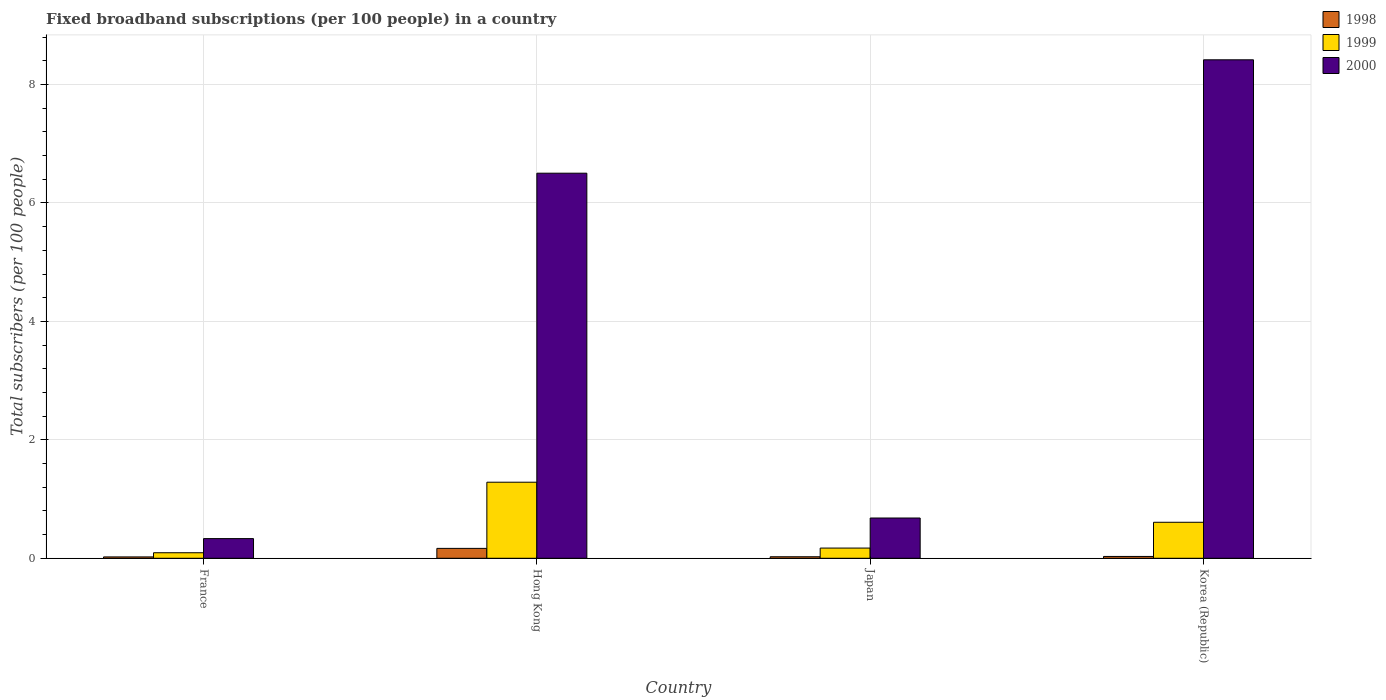How many different coloured bars are there?
Provide a succinct answer. 3. How many groups of bars are there?
Make the answer very short. 4. How many bars are there on the 3rd tick from the left?
Ensure brevity in your answer.  3. What is the label of the 4th group of bars from the left?
Provide a succinct answer. Korea (Republic). What is the number of broadband subscriptions in 2000 in Hong Kong?
Your answer should be very brief. 6.5. Across all countries, what is the maximum number of broadband subscriptions in 1998?
Ensure brevity in your answer.  0.17. Across all countries, what is the minimum number of broadband subscriptions in 2000?
Your response must be concise. 0.33. In which country was the number of broadband subscriptions in 1998 maximum?
Provide a short and direct response. Hong Kong. In which country was the number of broadband subscriptions in 2000 minimum?
Offer a very short reply. France. What is the total number of broadband subscriptions in 1998 in the graph?
Provide a succinct answer. 0.25. What is the difference between the number of broadband subscriptions in 2000 in Japan and that in Korea (Republic)?
Provide a succinct answer. -7.74. What is the difference between the number of broadband subscriptions in 2000 in France and the number of broadband subscriptions in 1998 in Japan?
Offer a very short reply. 0.31. What is the average number of broadband subscriptions in 2000 per country?
Make the answer very short. 3.98. What is the difference between the number of broadband subscriptions of/in 2000 and number of broadband subscriptions of/in 1998 in Korea (Republic)?
Make the answer very short. 8.39. In how many countries, is the number of broadband subscriptions in 1998 greater than 4.8?
Make the answer very short. 0. What is the ratio of the number of broadband subscriptions in 1999 in France to that in Korea (Republic)?
Provide a succinct answer. 0.15. What is the difference between the highest and the second highest number of broadband subscriptions in 1998?
Make the answer very short. 0.14. What is the difference between the highest and the lowest number of broadband subscriptions in 2000?
Ensure brevity in your answer.  8.09. In how many countries, is the number of broadband subscriptions in 1998 greater than the average number of broadband subscriptions in 1998 taken over all countries?
Your response must be concise. 1. What does the 3rd bar from the left in France represents?
Give a very brief answer. 2000. What does the 1st bar from the right in Japan represents?
Provide a succinct answer. 2000. How many bars are there?
Your answer should be compact. 12. Are all the bars in the graph horizontal?
Give a very brief answer. No. What is the difference between two consecutive major ticks on the Y-axis?
Ensure brevity in your answer.  2. Where does the legend appear in the graph?
Your answer should be compact. Top right. How are the legend labels stacked?
Keep it short and to the point. Vertical. What is the title of the graph?
Offer a very short reply. Fixed broadband subscriptions (per 100 people) in a country. Does "1975" appear as one of the legend labels in the graph?
Ensure brevity in your answer.  No. What is the label or title of the Y-axis?
Keep it short and to the point. Total subscribers (per 100 people). What is the Total subscribers (per 100 people) of 1998 in France?
Give a very brief answer. 0.02. What is the Total subscribers (per 100 people) of 1999 in France?
Your answer should be compact. 0.09. What is the Total subscribers (per 100 people) of 2000 in France?
Provide a succinct answer. 0.33. What is the Total subscribers (per 100 people) of 1998 in Hong Kong?
Your answer should be very brief. 0.17. What is the Total subscribers (per 100 people) in 1999 in Hong Kong?
Provide a succinct answer. 1.28. What is the Total subscribers (per 100 people) in 2000 in Hong Kong?
Your response must be concise. 6.5. What is the Total subscribers (per 100 people) in 1998 in Japan?
Give a very brief answer. 0.03. What is the Total subscribers (per 100 people) of 1999 in Japan?
Provide a succinct answer. 0.17. What is the Total subscribers (per 100 people) of 2000 in Japan?
Offer a terse response. 0.68. What is the Total subscribers (per 100 people) in 1998 in Korea (Republic)?
Provide a succinct answer. 0.03. What is the Total subscribers (per 100 people) in 1999 in Korea (Republic)?
Your answer should be very brief. 0.61. What is the Total subscribers (per 100 people) of 2000 in Korea (Republic)?
Your response must be concise. 8.42. Across all countries, what is the maximum Total subscribers (per 100 people) in 1998?
Keep it short and to the point. 0.17. Across all countries, what is the maximum Total subscribers (per 100 people) in 1999?
Provide a short and direct response. 1.28. Across all countries, what is the maximum Total subscribers (per 100 people) in 2000?
Give a very brief answer. 8.42. Across all countries, what is the minimum Total subscribers (per 100 people) in 1998?
Your answer should be compact. 0.02. Across all countries, what is the minimum Total subscribers (per 100 people) of 1999?
Your answer should be very brief. 0.09. Across all countries, what is the minimum Total subscribers (per 100 people) of 2000?
Keep it short and to the point. 0.33. What is the total Total subscribers (per 100 people) of 1998 in the graph?
Ensure brevity in your answer.  0.25. What is the total Total subscribers (per 100 people) of 1999 in the graph?
Offer a terse response. 2.16. What is the total Total subscribers (per 100 people) of 2000 in the graph?
Provide a succinct answer. 15.93. What is the difference between the Total subscribers (per 100 people) in 1998 in France and that in Hong Kong?
Offer a terse response. -0.14. What is the difference between the Total subscribers (per 100 people) of 1999 in France and that in Hong Kong?
Give a very brief answer. -1.19. What is the difference between the Total subscribers (per 100 people) of 2000 in France and that in Hong Kong?
Provide a short and direct response. -6.17. What is the difference between the Total subscribers (per 100 people) of 1998 in France and that in Japan?
Provide a succinct answer. -0. What is the difference between the Total subscribers (per 100 people) in 1999 in France and that in Japan?
Your response must be concise. -0.08. What is the difference between the Total subscribers (per 100 people) in 2000 in France and that in Japan?
Offer a terse response. -0.35. What is the difference between the Total subscribers (per 100 people) in 1998 in France and that in Korea (Republic)?
Make the answer very short. -0.01. What is the difference between the Total subscribers (per 100 people) of 1999 in France and that in Korea (Republic)?
Keep it short and to the point. -0.51. What is the difference between the Total subscribers (per 100 people) in 2000 in France and that in Korea (Republic)?
Offer a very short reply. -8.09. What is the difference between the Total subscribers (per 100 people) in 1998 in Hong Kong and that in Japan?
Your answer should be compact. 0.14. What is the difference between the Total subscribers (per 100 people) of 1999 in Hong Kong and that in Japan?
Provide a short and direct response. 1.11. What is the difference between the Total subscribers (per 100 people) in 2000 in Hong Kong and that in Japan?
Offer a terse response. 5.82. What is the difference between the Total subscribers (per 100 people) of 1998 in Hong Kong and that in Korea (Republic)?
Your response must be concise. 0.14. What is the difference between the Total subscribers (per 100 people) in 1999 in Hong Kong and that in Korea (Republic)?
Keep it short and to the point. 0.68. What is the difference between the Total subscribers (per 100 people) of 2000 in Hong Kong and that in Korea (Republic)?
Ensure brevity in your answer.  -1.91. What is the difference between the Total subscribers (per 100 people) in 1998 in Japan and that in Korea (Republic)?
Offer a very short reply. -0.01. What is the difference between the Total subscribers (per 100 people) in 1999 in Japan and that in Korea (Republic)?
Your response must be concise. -0.44. What is the difference between the Total subscribers (per 100 people) of 2000 in Japan and that in Korea (Republic)?
Offer a very short reply. -7.74. What is the difference between the Total subscribers (per 100 people) in 1998 in France and the Total subscribers (per 100 people) in 1999 in Hong Kong?
Your answer should be very brief. -1.26. What is the difference between the Total subscribers (per 100 people) of 1998 in France and the Total subscribers (per 100 people) of 2000 in Hong Kong?
Your answer should be compact. -6.48. What is the difference between the Total subscribers (per 100 people) in 1999 in France and the Total subscribers (per 100 people) in 2000 in Hong Kong?
Your response must be concise. -6.41. What is the difference between the Total subscribers (per 100 people) of 1998 in France and the Total subscribers (per 100 people) of 1999 in Japan?
Offer a terse response. -0.15. What is the difference between the Total subscribers (per 100 people) in 1998 in France and the Total subscribers (per 100 people) in 2000 in Japan?
Your response must be concise. -0.66. What is the difference between the Total subscribers (per 100 people) in 1999 in France and the Total subscribers (per 100 people) in 2000 in Japan?
Keep it short and to the point. -0.59. What is the difference between the Total subscribers (per 100 people) of 1998 in France and the Total subscribers (per 100 people) of 1999 in Korea (Republic)?
Ensure brevity in your answer.  -0.58. What is the difference between the Total subscribers (per 100 people) in 1998 in France and the Total subscribers (per 100 people) in 2000 in Korea (Republic)?
Offer a very short reply. -8.39. What is the difference between the Total subscribers (per 100 people) in 1999 in France and the Total subscribers (per 100 people) in 2000 in Korea (Republic)?
Offer a terse response. -8.32. What is the difference between the Total subscribers (per 100 people) of 1998 in Hong Kong and the Total subscribers (per 100 people) of 1999 in Japan?
Make the answer very short. -0.01. What is the difference between the Total subscribers (per 100 people) of 1998 in Hong Kong and the Total subscribers (per 100 people) of 2000 in Japan?
Provide a succinct answer. -0.51. What is the difference between the Total subscribers (per 100 people) of 1999 in Hong Kong and the Total subscribers (per 100 people) of 2000 in Japan?
Your response must be concise. 0.6. What is the difference between the Total subscribers (per 100 people) in 1998 in Hong Kong and the Total subscribers (per 100 people) in 1999 in Korea (Republic)?
Provide a short and direct response. -0.44. What is the difference between the Total subscribers (per 100 people) in 1998 in Hong Kong and the Total subscribers (per 100 people) in 2000 in Korea (Republic)?
Your answer should be compact. -8.25. What is the difference between the Total subscribers (per 100 people) of 1999 in Hong Kong and the Total subscribers (per 100 people) of 2000 in Korea (Republic)?
Make the answer very short. -7.13. What is the difference between the Total subscribers (per 100 people) in 1998 in Japan and the Total subscribers (per 100 people) in 1999 in Korea (Republic)?
Give a very brief answer. -0.58. What is the difference between the Total subscribers (per 100 people) of 1998 in Japan and the Total subscribers (per 100 people) of 2000 in Korea (Republic)?
Your answer should be compact. -8.39. What is the difference between the Total subscribers (per 100 people) in 1999 in Japan and the Total subscribers (per 100 people) in 2000 in Korea (Republic)?
Provide a short and direct response. -8.25. What is the average Total subscribers (per 100 people) of 1998 per country?
Provide a short and direct response. 0.06. What is the average Total subscribers (per 100 people) of 1999 per country?
Your answer should be very brief. 0.54. What is the average Total subscribers (per 100 people) of 2000 per country?
Your answer should be compact. 3.98. What is the difference between the Total subscribers (per 100 people) in 1998 and Total subscribers (per 100 people) in 1999 in France?
Give a very brief answer. -0.07. What is the difference between the Total subscribers (per 100 people) in 1998 and Total subscribers (per 100 people) in 2000 in France?
Ensure brevity in your answer.  -0.31. What is the difference between the Total subscribers (per 100 people) in 1999 and Total subscribers (per 100 people) in 2000 in France?
Offer a very short reply. -0.24. What is the difference between the Total subscribers (per 100 people) of 1998 and Total subscribers (per 100 people) of 1999 in Hong Kong?
Your answer should be very brief. -1.12. What is the difference between the Total subscribers (per 100 people) of 1998 and Total subscribers (per 100 people) of 2000 in Hong Kong?
Ensure brevity in your answer.  -6.34. What is the difference between the Total subscribers (per 100 people) of 1999 and Total subscribers (per 100 people) of 2000 in Hong Kong?
Offer a terse response. -5.22. What is the difference between the Total subscribers (per 100 people) of 1998 and Total subscribers (per 100 people) of 1999 in Japan?
Provide a short and direct response. -0.15. What is the difference between the Total subscribers (per 100 people) in 1998 and Total subscribers (per 100 people) in 2000 in Japan?
Provide a succinct answer. -0.65. What is the difference between the Total subscribers (per 100 people) of 1999 and Total subscribers (per 100 people) of 2000 in Japan?
Provide a succinct answer. -0.51. What is the difference between the Total subscribers (per 100 people) in 1998 and Total subscribers (per 100 people) in 1999 in Korea (Republic)?
Make the answer very short. -0.58. What is the difference between the Total subscribers (per 100 people) in 1998 and Total subscribers (per 100 people) in 2000 in Korea (Republic)?
Make the answer very short. -8.39. What is the difference between the Total subscribers (per 100 people) of 1999 and Total subscribers (per 100 people) of 2000 in Korea (Republic)?
Provide a short and direct response. -7.81. What is the ratio of the Total subscribers (per 100 people) of 1998 in France to that in Hong Kong?
Keep it short and to the point. 0.14. What is the ratio of the Total subscribers (per 100 people) in 1999 in France to that in Hong Kong?
Make the answer very short. 0.07. What is the ratio of the Total subscribers (per 100 people) in 2000 in France to that in Hong Kong?
Your answer should be compact. 0.05. What is the ratio of the Total subscribers (per 100 people) in 1998 in France to that in Japan?
Provide a short and direct response. 0.9. What is the ratio of the Total subscribers (per 100 people) of 1999 in France to that in Japan?
Give a very brief answer. 0.54. What is the ratio of the Total subscribers (per 100 people) of 2000 in France to that in Japan?
Your answer should be compact. 0.49. What is the ratio of the Total subscribers (per 100 people) of 1998 in France to that in Korea (Republic)?
Provide a succinct answer. 0.75. What is the ratio of the Total subscribers (per 100 people) in 1999 in France to that in Korea (Republic)?
Offer a terse response. 0.15. What is the ratio of the Total subscribers (per 100 people) in 2000 in France to that in Korea (Republic)?
Ensure brevity in your answer.  0.04. What is the ratio of the Total subscribers (per 100 people) in 1998 in Hong Kong to that in Japan?
Offer a terse response. 6.53. What is the ratio of the Total subscribers (per 100 people) of 1999 in Hong Kong to that in Japan?
Make the answer very short. 7.46. What is the ratio of the Total subscribers (per 100 people) in 2000 in Hong Kong to that in Japan?
Make the answer very short. 9.56. What is the ratio of the Total subscribers (per 100 people) of 1998 in Hong Kong to that in Korea (Republic)?
Your answer should be very brief. 5.42. What is the ratio of the Total subscribers (per 100 people) of 1999 in Hong Kong to that in Korea (Republic)?
Your answer should be very brief. 2.11. What is the ratio of the Total subscribers (per 100 people) of 2000 in Hong Kong to that in Korea (Republic)?
Your response must be concise. 0.77. What is the ratio of the Total subscribers (per 100 people) of 1998 in Japan to that in Korea (Republic)?
Make the answer very short. 0.83. What is the ratio of the Total subscribers (per 100 people) in 1999 in Japan to that in Korea (Republic)?
Keep it short and to the point. 0.28. What is the ratio of the Total subscribers (per 100 people) of 2000 in Japan to that in Korea (Republic)?
Your answer should be very brief. 0.08. What is the difference between the highest and the second highest Total subscribers (per 100 people) in 1998?
Make the answer very short. 0.14. What is the difference between the highest and the second highest Total subscribers (per 100 people) in 1999?
Offer a very short reply. 0.68. What is the difference between the highest and the second highest Total subscribers (per 100 people) of 2000?
Keep it short and to the point. 1.91. What is the difference between the highest and the lowest Total subscribers (per 100 people) in 1998?
Ensure brevity in your answer.  0.14. What is the difference between the highest and the lowest Total subscribers (per 100 people) of 1999?
Ensure brevity in your answer.  1.19. What is the difference between the highest and the lowest Total subscribers (per 100 people) of 2000?
Provide a short and direct response. 8.09. 